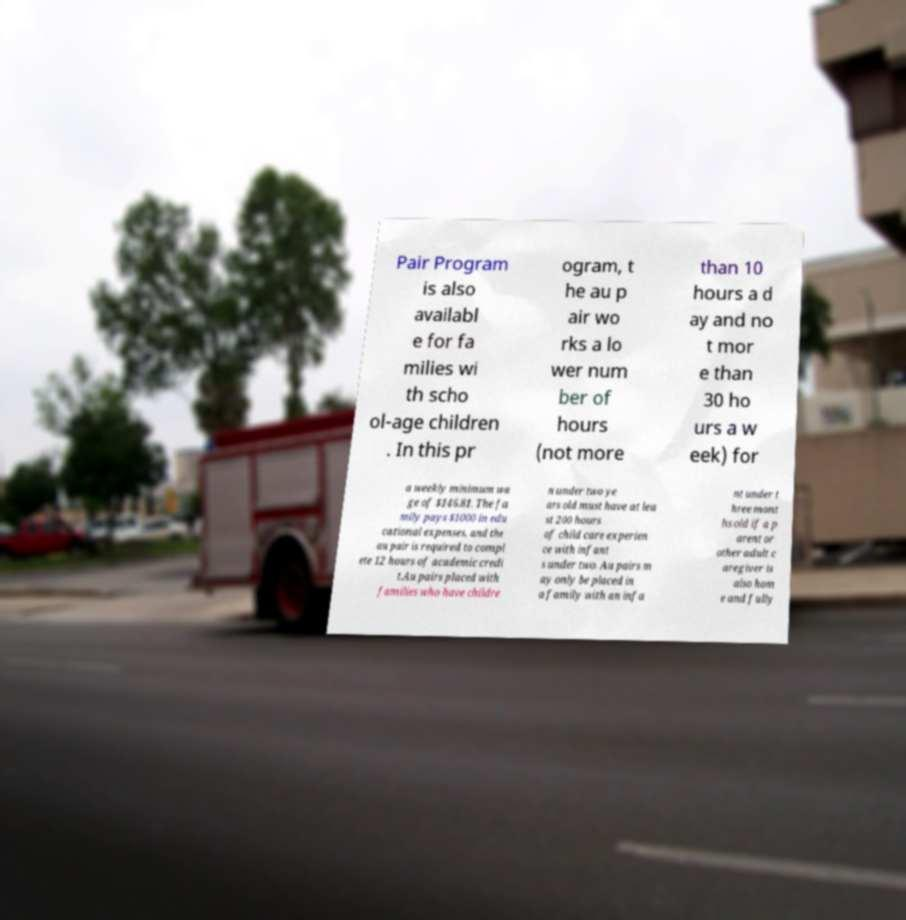Please read and relay the text visible in this image. What does it say? Pair Program is also availabl e for fa milies wi th scho ol-age children . In this pr ogram, t he au p air wo rks a lo wer num ber of hours (not more than 10 hours a d ay and no t mor e than 30 ho urs a w eek) for a weekly minimum wa ge of $146.81. The fa mily pays $1000 in edu cational expenses, and the au pair is required to compl ete 12 hours of academic credi t.Au pairs placed with families who have childre n under two ye ars old must have at lea st 200 hours of child care experien ce with infant s under two. Au pairs m ay only be placed in a family with an infa nt under t hree mont hs old if a p arent or other adult c aregiver is also hom e and fully 